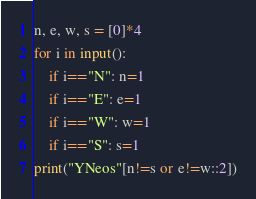<code> <loc_0><loc_0><loc_500><loc_500><_Python_>n, e, w, s = [0]*4
for i in input():
    if i=="N": n=1
    if i=="E": e=1
    if i=="W": w=1
    if i=="S": s=1
print("YNeos"[n!=s or e!=w::2])</code> 